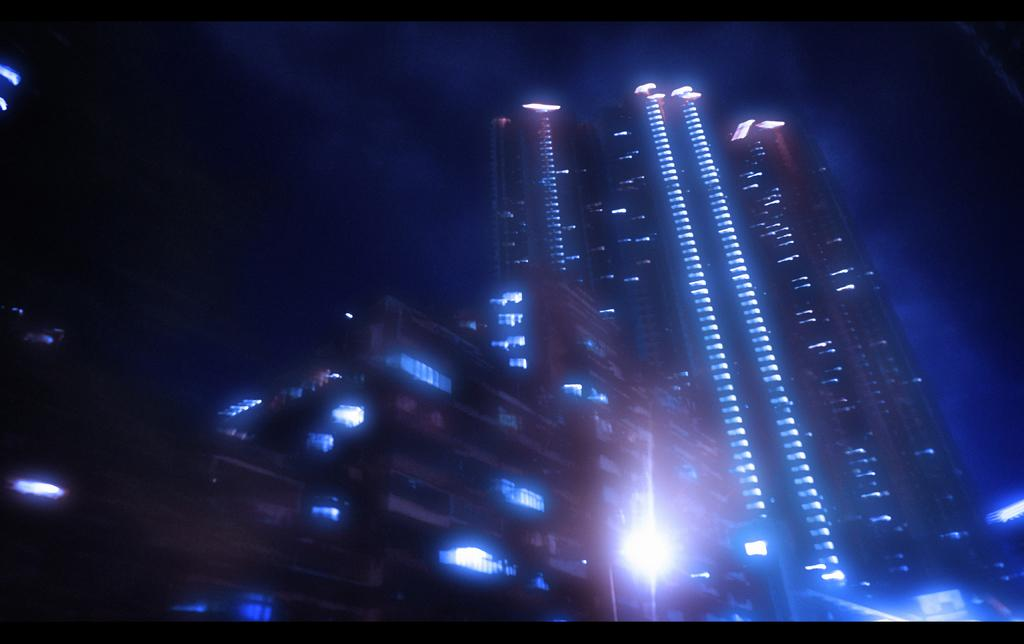What type of structures are present in the image? There are skyscrapers and buildings in the image. What feature do the buildings have? The buildings have lights. What is visible at the top of the image? The sky is visible at the top of the image. What type of unit is being measured in the image? There is no unit being measured in the image; it primarily features skyscrapers, buildings, and lights. 